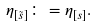Convert formula to latex. <formula><loc_0><loc_0><loc_500><loc_500>\eta _ { [ \tilde { s } ] } \colon = \eta _ { [ { s } ] } .</formula> 